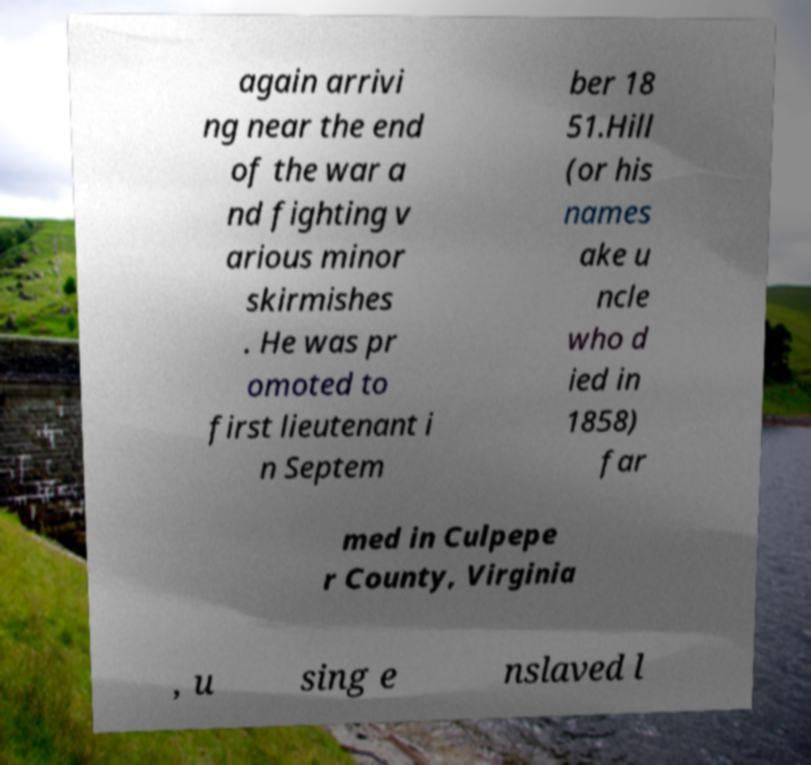Could you assist in decoding the text presented in this image and type it out clearly? again arrivi ng near the end of the war a nd fighting v arious minor skirmishes . He was pr omoted to first lieutenant i n Septem ber 18 51.Hill (or his names ake u ncle who d ied in 1858) far med in Culpepe r County, Virginia , u sing e nslaved l 